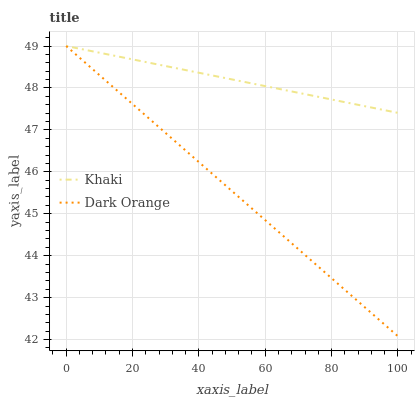Does Khaki have the minimum area under the curve?
Answer yes or no. No. Is Khaki the smoothest?
Answer yes or no. No. Does Khaki have the lowest value?
Answer yes or no. No. 